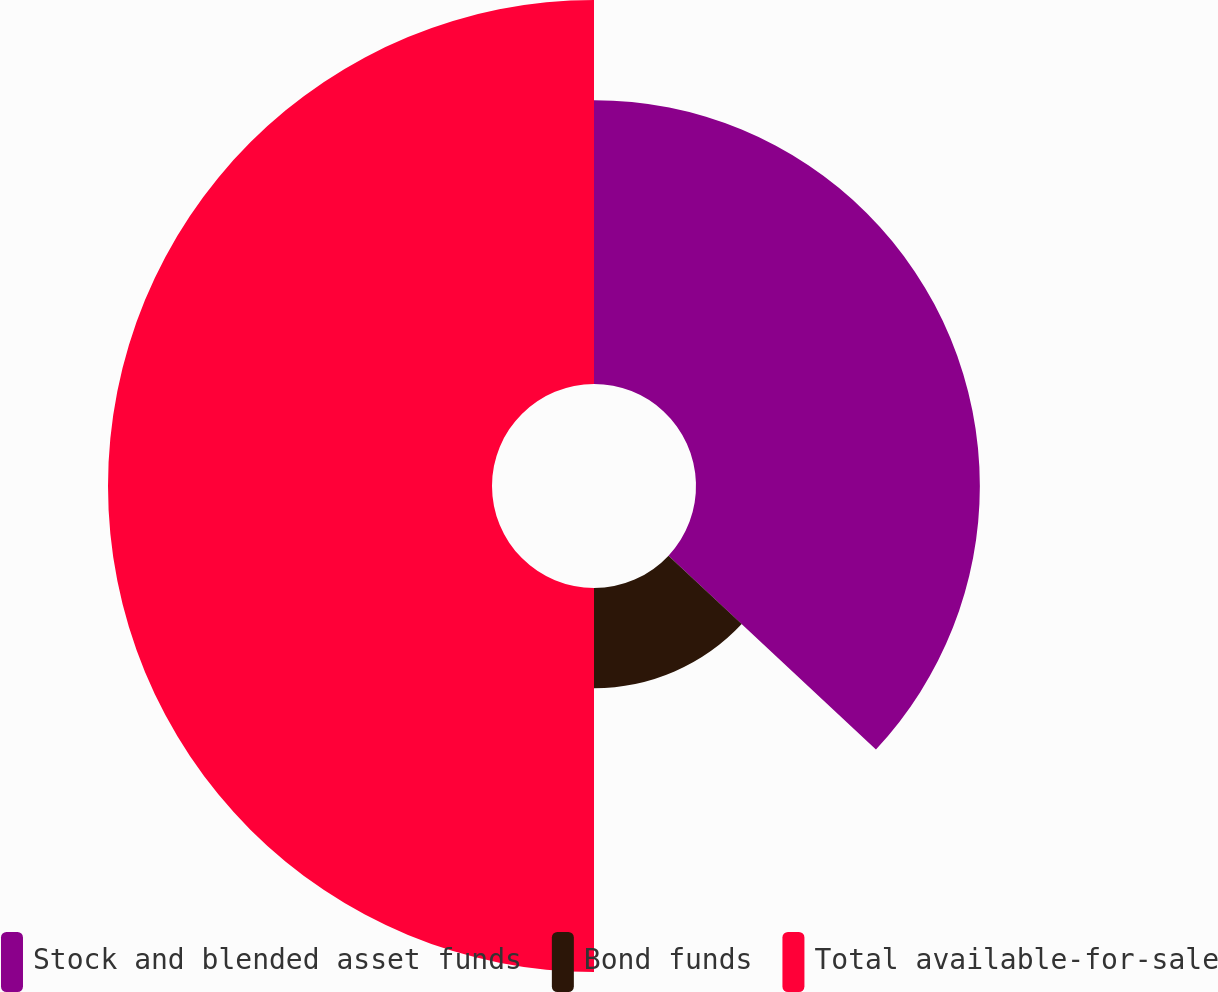<chart> <loc_0><loc_0><loc_500><loc_500><pie_chart><fcel>Stock and blended asset funds<fcel>Bond funds<fcel>Total available-for-sale<nl><fcel>36.96%<fcel>13.04%<fcel>50.0%<nl></chart> 